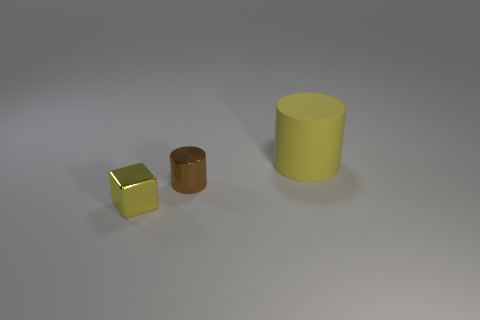Add 2 tiny purple objects. How many objects exist? 5 Subtract all cylinders. How many objects are left? 1 Subtract 0 purple cubes. How many objects are left? 3 Subtract all big yellow matte objects. Subtract all large blue cylinders. How many objects are left? 2 Add 1 big yellow matte objects. How many big yellow matte objects are left? 2 Add 3 matte cylinders. How many matte cylinders exist? 4 